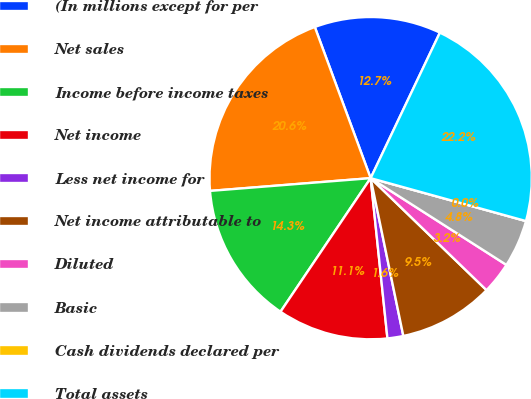<chart> <loc_0><loc_0><loc_500><loc_500><pie_chart><fcel>(In millions except for per<fcel>Net sales<fcel>Income before income taxes<fcel>Net income<fcel>Less net income for<fcel>Net income attributable to<fcel>Diluted<fcel>Basic<fcel>Cash dividends declared per<fcel>Total assets<nl><fcel>12.7%<fcel>20.63%<fcel>14.29%<fcel>11.11%<fcel>1.59%<fcel>9.52%<fcel>3.18%<fcel>4.76%<fcel>0.0%<fcel>22.22%<nl></chart> 